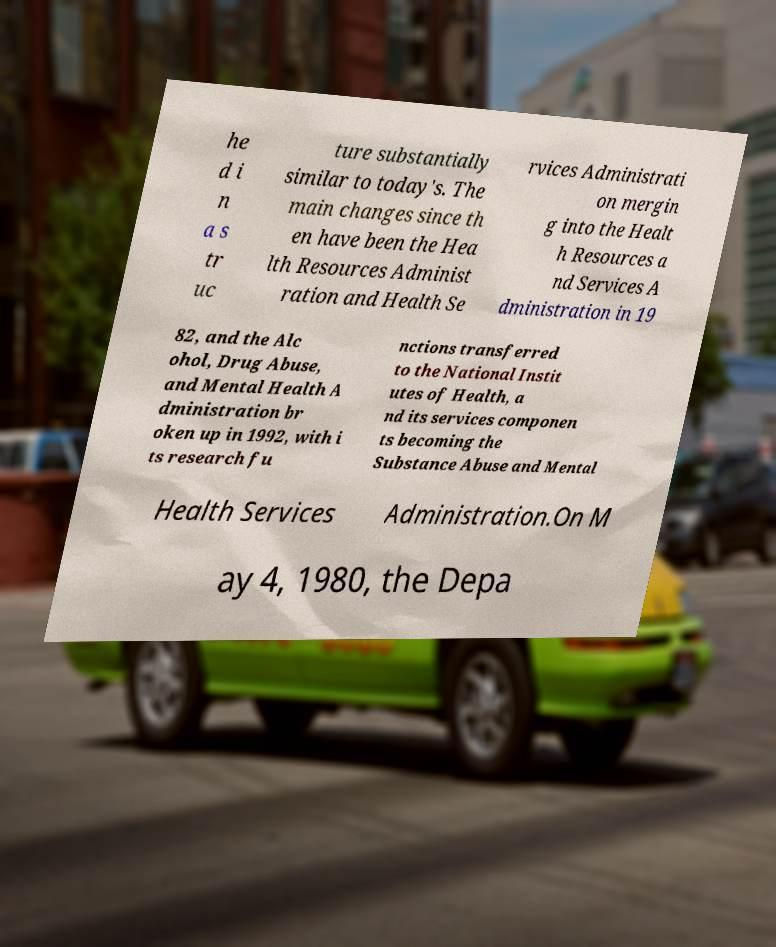Can you read and provide the text displayed in the image?This photo seems to have some interesting text. Can you extract and type it out for me? he d i n a s tr uc ture substantially similar to today's. The main changes since th en have been the Hea lth Resources Administ ration and Health Se rvices Administrati on mergin g into the Healt h Resources a nd Services A dministration in 19 82, and the Alc ohol, Drug Abuse, and Mental Health A dministration br oken up in 1992, with i ts research fu nctions transferred to the National Instit utes of Health, a nd its services componen ts becoming the Substance Abuse and Mental Health Services Administration.On M ay 4, 1980, the Depa 